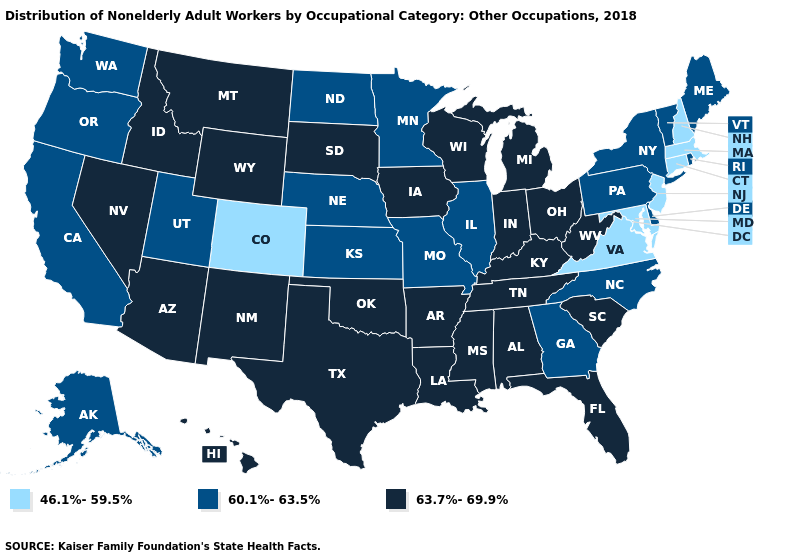Which states have the lowest value in the Northeast?
Answer briefly. Connecticut, Massachusetts, New Hampshire, New Jersey. What is the value of Maryland?
Quick response, please. 46.1%-59.5%. What is the value of Texas?
Quick response, please. 63.7%-69.9%. Name the states that have a value in the range 60.1%-63.5%?
Give a very brief answer. Alaska, California, Delaware, Georgia, Illinois, Kansas, Maine, Minnesota, Missouri, Nebraska, New York, North Carolina, North Dakota, Oregon, Pennsylvania, Rhode Island, Utah, Vermont, Washington. Which states have the lowest value in the USA?
Concise answer only. Colorado, Connecticut, Maryland, Massachusetts, New Hampshire, New Jersey, Virginia. What is the highest value in the South ?
Give a very brief answer. 63.7%-69.9%. What is the value of Louisiana?
Write a very short answer. 63.7%-69.9%. What is the value of Louisiana?
Keep it brief. 63.7%-69.9%. How many symbols are there in the legend?
Write a very short answer. 3. Does North Carolina have a higher value than Maryland?
Give a very brief answer. Yes. What is the value of Wisconsin?
Write a very short answer. 63.7%-69.9%. Does Illinois have a lower value than Washington?
Give a very brief answer. No. Does Tennessee have the lowest value in the South?
Short answer required. No. Name the states that have a value in the range 46.1%-59.5%?
Be succinct. Colorado, Connecticut, Maryland, Massachusetts, New Hampshire, New Jersey, Virginia. 